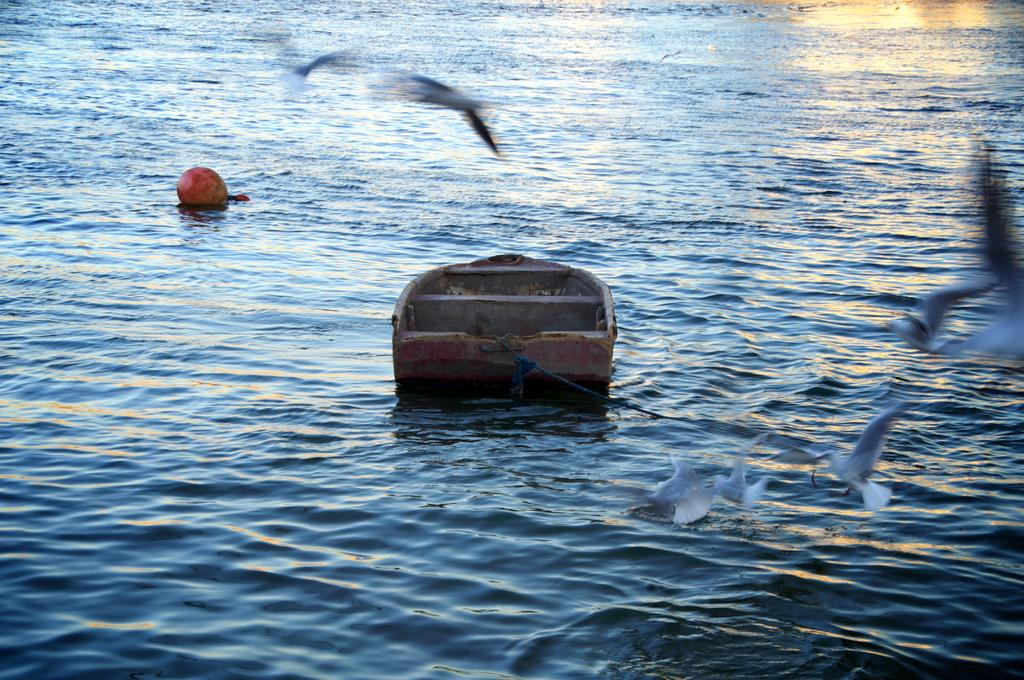What is the primary element in the image? There is water in the image. What can be seen floating on the water? There are objects floating on the water. What type of animals are visible in the image? Birds are flying in the image. Where is the zoo located in the image? There is no zoo present in the image. What angle is the camera positioned at in the image? The angle of the camera is not mentioned in the provided facts, so it cannot be determined from the image. 